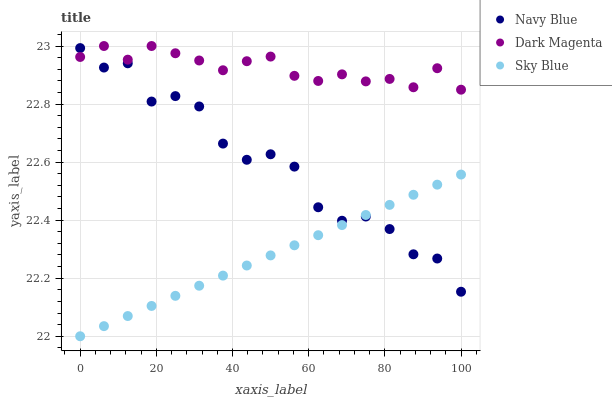Does Sky Blue have the minimum area under the curve?
Answer yes or no. Yes. Does Dark Magenta have the maximum area under the curve?
Answer yes or no. Yes. Does Dark Magenta have the minimum area under the curve?
Answer yes or no. No. Does Sky Blue have the maximum area under the curve?
Answer yes or no. No. Is Sky Blue the smoothest?
Answer yes or no. Yes. Is Navy Blue the roughest?
Answer yes or no. Yes. Is Dark Magenta the smoothest?
Answer yes or no. No. Is Dark Magenta the roughest?
Answer yes or no. No. Does Sky Blue have the lowest value?
Answer yes or no. Yes. Does Dark Magenta have the lowest value?
Answer yes or no. No. Does Dark Magenta have the highest value?
Answer yes or no. Yes. Does Sky Blue have the highest value?
Answer yes or no. No. Is Sky Blue less than Dark Magenta?
Answer yes or no. Yes. Is Dark Magenta greater than Sky Blue?
Answer yes or no. Yes. Does Sky Blue intersect Navy Blue?
Answer yes or no. Yes. Is Sky Blue less than Navy Blue?
Answer yes or no. No. Is Sky Blue greater than Navy Blue?
Answer yes or no. No. Does Sky Blue intersect Dark Magenta?
Answer yes or no. No. 